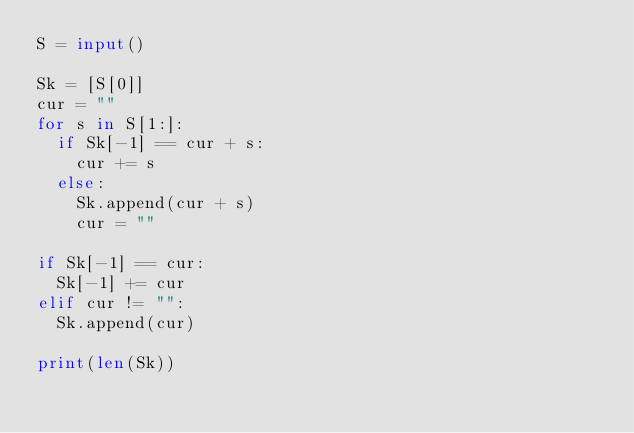<code> <loc_0><loc_0><loc_500><loc_500><_Python_>S = input()

Sk = [S[0]]
cur = ""
for s in S[1:]:
  if Sk[-1] == cur + s:
    cur += s
  else:
    Sk.append(cur + s)
    cur = ""

if Sk[-1] == cur:
  Sk[-1] += cur
elif cur != "":
  Sk.append(cur)

print(len(Sk))</code> 